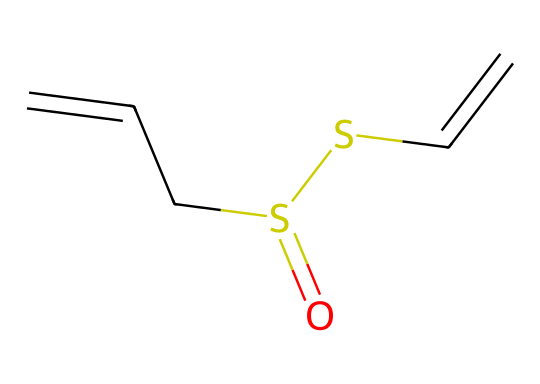What is the molecular formula of allicin? To determine the molecular formula from the given SMILES representation, count each type of atom: carbon (C), hydrogen (H), sulfur (S), and oxygen (O). The structure indicates there are 6 carbons, 10 hydrogens, 2 sulfurs, and 1 oxygen. Therefore, the molecular formula is C6H10O2S2.
Answer: C6H10O2S2 How many sulfur atoms are in the structure? By examining the provided SMILES, there are two 'S' letters present, which represent sulfur atoms. Hence, the count of sulfur atoms is 2.
Answer: 2 What type of compound is allicin classified as? Allicin is specifically classified as an organosulfur compound because it contains sulfur atoms integrated into its organic structure.
Answer: organosulfur How many double bonds are present in allicin? Analyzing the SMILES representation, there are double bonds indicated by '='. In the structure, there are two '=' symbols, which signify 2 double bonds in the allicin molecule.
Answer: 2 What functional groups can be identified in allicin? The SMILES representation reveals both a thioether (–S–) and a sulfoxide (C=O) functional group based on the sulfur and oxygen atoms' arrangement and bonding in the structure; hence, these are present in allicin.
Answer: thioether, sulfoxide What is the significance of the double bonds in allicin's structure? The presence of double bonds in allicin, specifically the C=C bonds, contributes to the compound's reactivity and stability, and they are crucial for its biological activity, particularly its antibacterial properties. These unsaturations provide the compound with specific spatial arrangements that are essential for its function.
Answer: reactivity and biological activity 